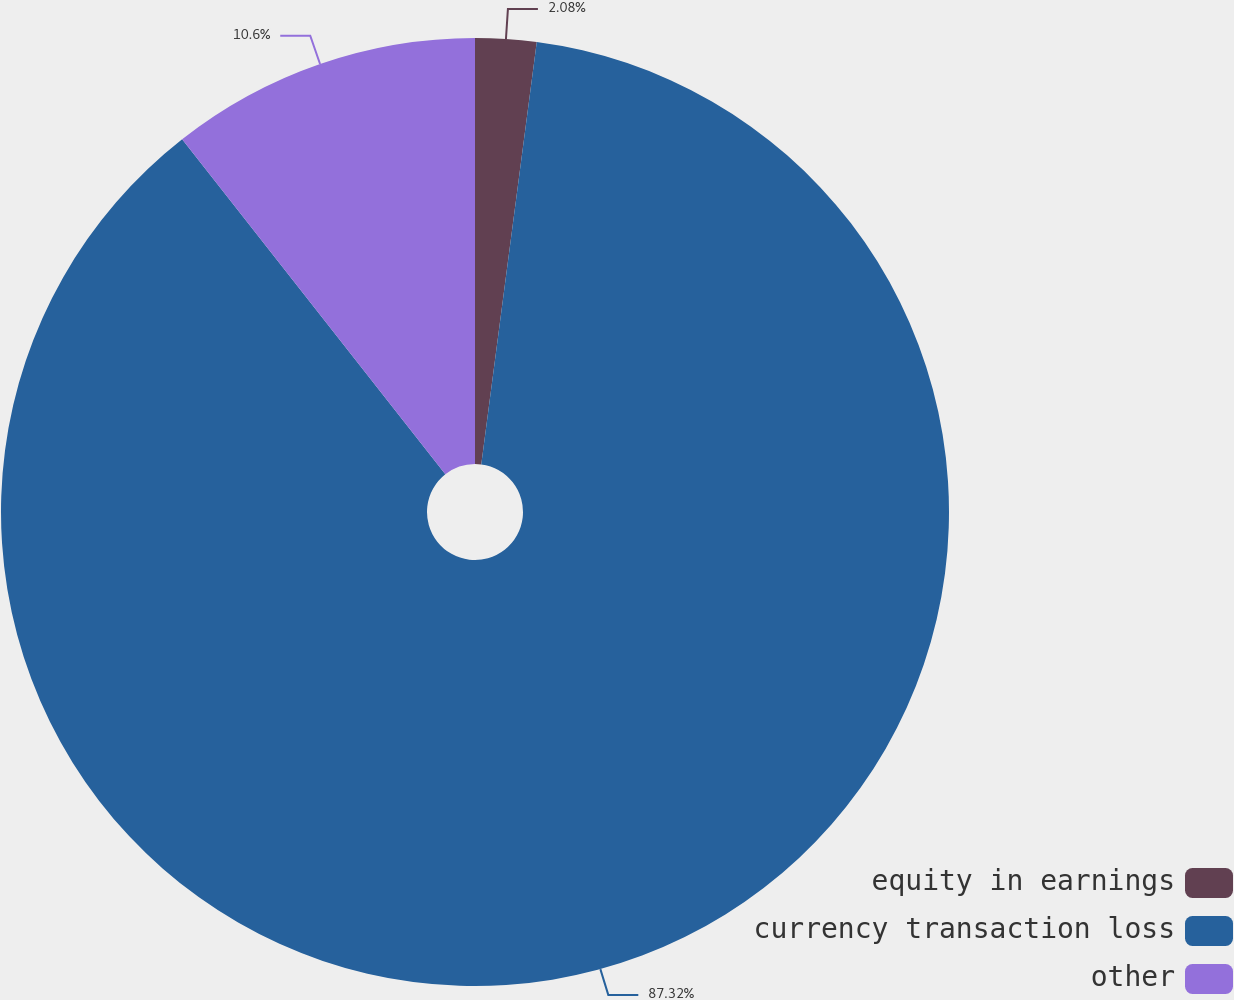<chart> <loc_0><loc_0><loc_500><loc_500><pie_chart><fcel>equity in earnings<fcel>currency transaction loss<fcel>other<nl><fcel>2.08%<fcel>87.32%<fcel>10.6%<nl></chart> 